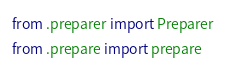Convert code to text. <code><loc_0><loc_0><loc_500><loc_500><_Python_>from .preparer import Preparer
from .prepare import prepare
</code> 